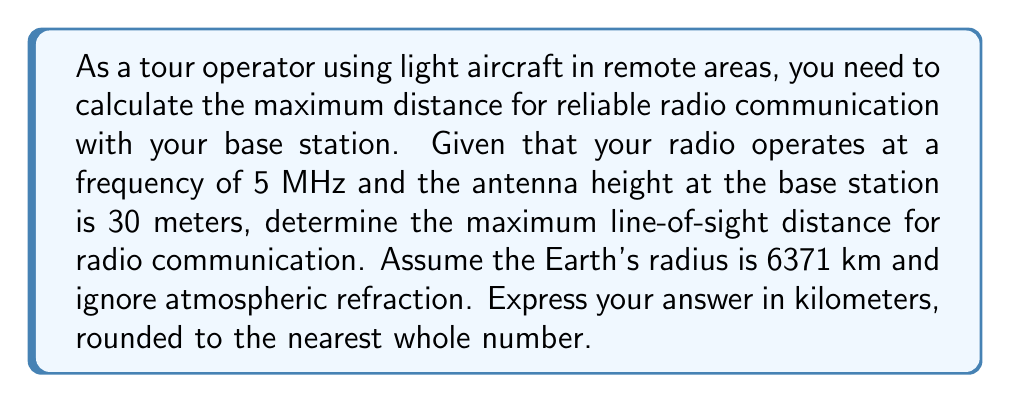Help me with this question. To solve this problem, we'll use the formula for the radio horizon, which is based on the curvature of the Earth. The steps are as follows:

1) The formula for the radio horizon distance $d$ in kilometers, given the antenna height $h$ in meters, is:

   $$d = \sqrt{2Rh}$$

   where $R$ is the Earth's radius in kilometers.

2) We're given:
   - $R = 6371$ km (Earth's radius)
   - $h = 30$ m (antenna height)

3) Let's substitute these values into our equation:

   $$d = \sqrt{2 \cdot 6371 \cdot 0.030}$$

4) Simplify inside the square root:

   $$d = \sqrt{382.26}$$

5) Calculate the square root:

   $$d \approx 19.55 \text{ km}$$

6) Rounding to the nearest whole number:

   $$d \approx 20 \text{ km}$$

This is the maximum line-of-sight distance for radio communication given the specified conditions.
Answer: 20 km 